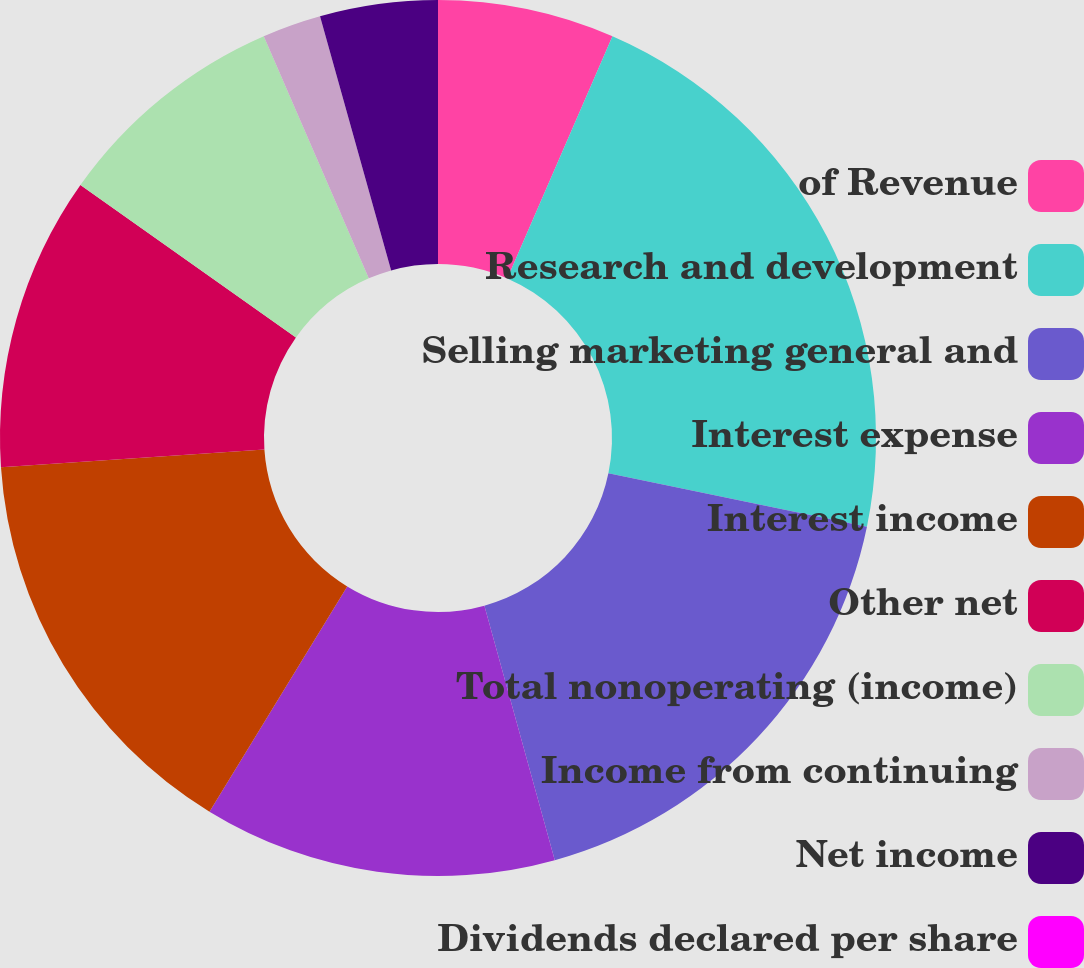Convert chart to OTSL. <chart><loc_0><loc_0><loc_500><loc_500><pie_chart><fcel>of Revenue<fcel>Research and development<fcel>Selling marketing general and<fcel>Interest expense<fcel>Interest income<fcel>Other net<fcel>Total nonoperating (income)<fcel>Income from continuing<fcel>Net income<fcel>Dividends declared per share<nl><fcel>6.52%<fcel>21.72%<fcel>17.46%<fcel>13.03%<fcel>15.2%<fcel>10.86%<fcel>8.69%<fcel>2.17%<fcel>4.34%<fcel>0.0%<nl></chart> 